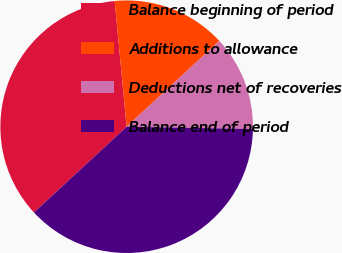Convert chart to OTSL. <chart><loc_0><loc_0><loc_500><loc_500><pie_chart><fcel>Balance beginning of period<fcel>Additions to allowance<fcel>Deductions net of recoveries<fcel>Balance end of period<nl><fcel>35.37%<fcel>14.63%<fcel>12.18%<fcel>37.82%<nl></chart> 